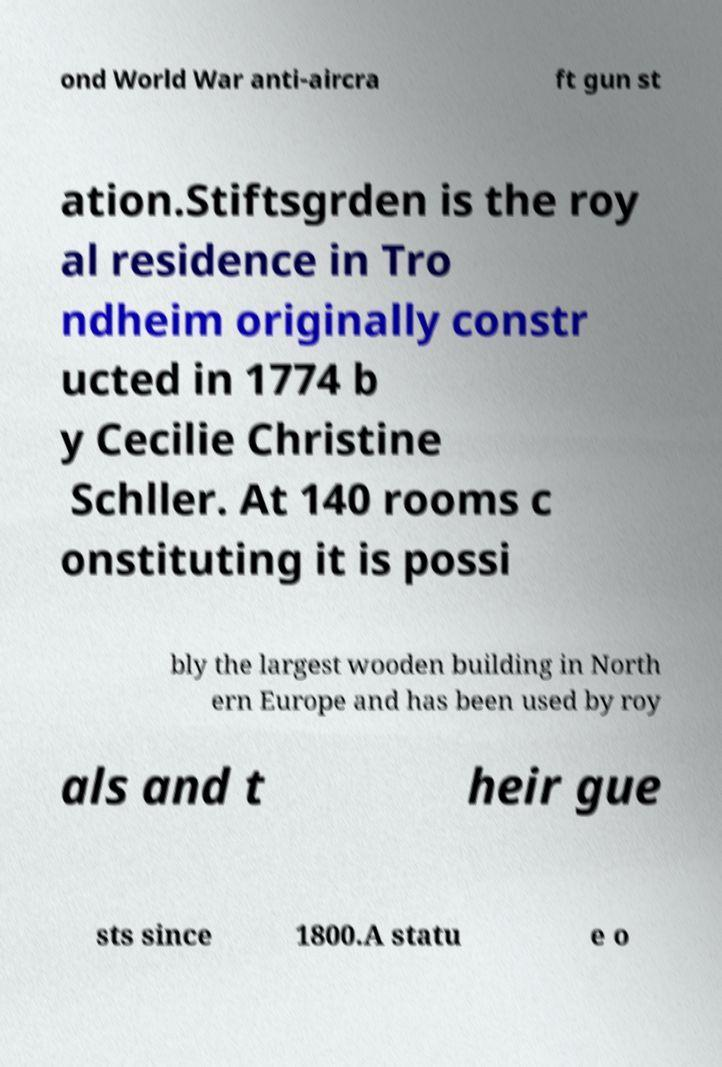Please identify and transcribe the text found in this image. ond World War anti-aircra ft gun st ation.Stiftsgrden is the roy al residence in Tro ndheim originally constr ucted in 1774 b y Cecilie Christine Schller. At 140 rooms c onstituting it is possi bly the largest wooden building in North ern Europe and has been used by roy als and t heir gue sts since 1800.A statu e o 